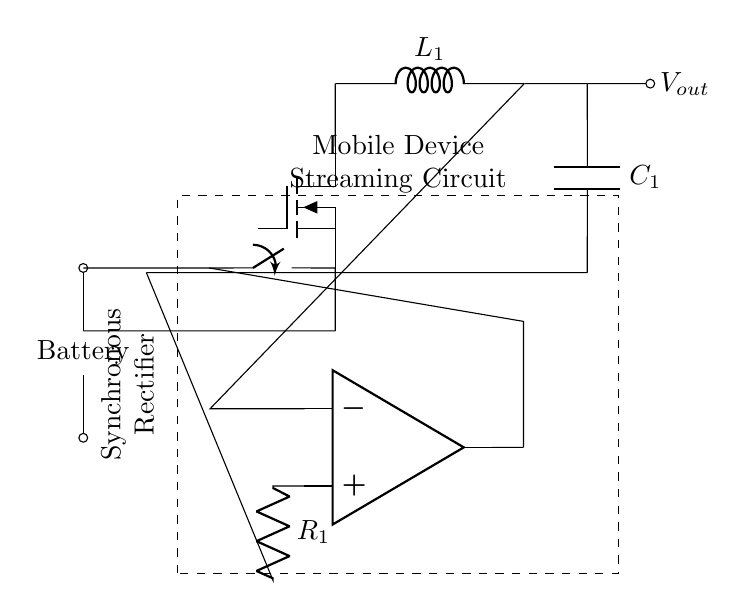What type of rectifier is shown in this circuit? The circuit uses a synchronous rectifier, which is indicated by the marking in the dashed rectangle around the main components, including the switch and the N-channel MOSFET.
Answer: synchronous rectifier What is the purpose of the inductor in the circuit? The inductor, labeled as L1, serves to store energy and smooth the output current during operation, particularly when the load demands more power. This helps improve efficiency, especially in battery-powered devices.
Answer: store energy Which component is responsible for controlling the output voltage? The operational amplifier, indicated as OA, monitors the output voltage and adjusts the switching operation of the circuit to maintain a constant output.
Answer: operational amplifier How many nodes are in the circuit labeled 'GND'? There are three distinct points in the circuit labeled 'GND', which shows multiple ground connections throughout the circuit.
Answer: three What does the capacitor labeled C1 do in this circuit? The capacitor C1 acts as a filter component. It smooths out the voltage fluctuations at the output, ensuring a stable voltage supply for the mobile device.
Answer: smooth voltage What is the role of the switch shown in the circuit? The switch connects or disconnects the synchronous rectifier from the battery supply, enabling or disabling the rectification process based on the demand from the load.
Answer: connect/disconnect Which component helps to improve battery life in this synchronous rectifier circuit? The use of a synchronous rectifier, which includes a MOSFET as opposed to a traditional diode, minimizes voltage drops and increases efficiency, thus extending battery life.
Answer: MOSFET 